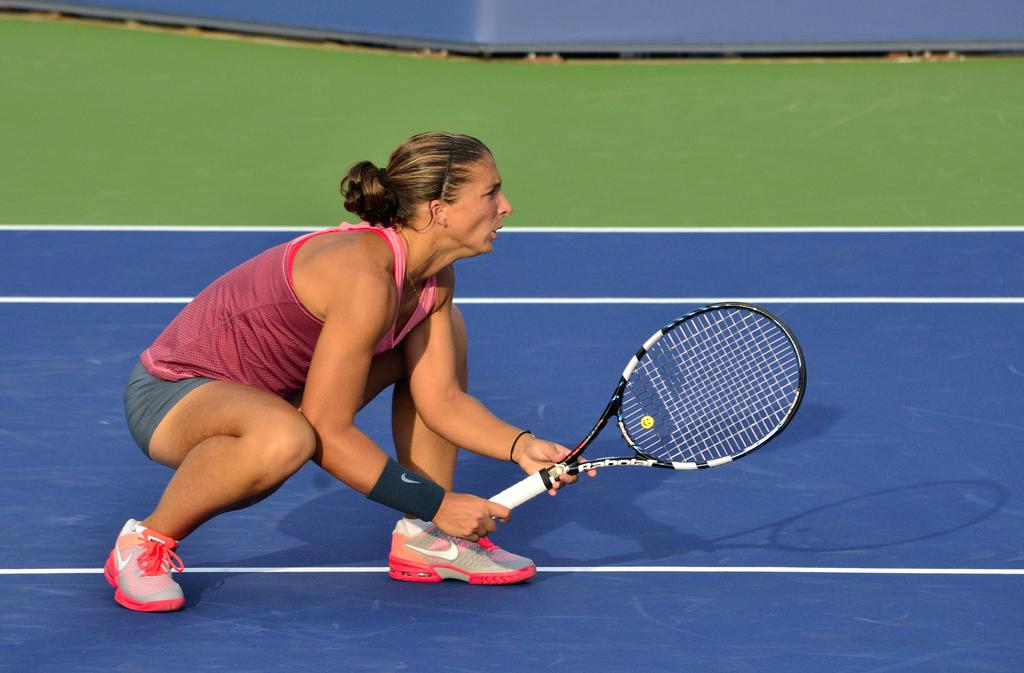Who is in the image? There is a lady in the image. What position is the lady in? The lady is in a squat position. What is the lady holding in the image? The lady is holding a badminton racket. What type of footwear is the lady wearing? The lady is wearing shoes. Where is the lady located? The lady is on a court. What type of bun is the lady eating while playing badminton in the image? There is no bun present in the image; the lady is holding a badminton racket and is not eating anything. What type of voyage is the lady embarking on while playing badminton in the image? There is no voyage present in the image; the lady is playing badminton on a court. Can you see any rabbits on the court with the lady in the image? There are no rabbits present in the image; the lady is playing badminton alone on the court. 